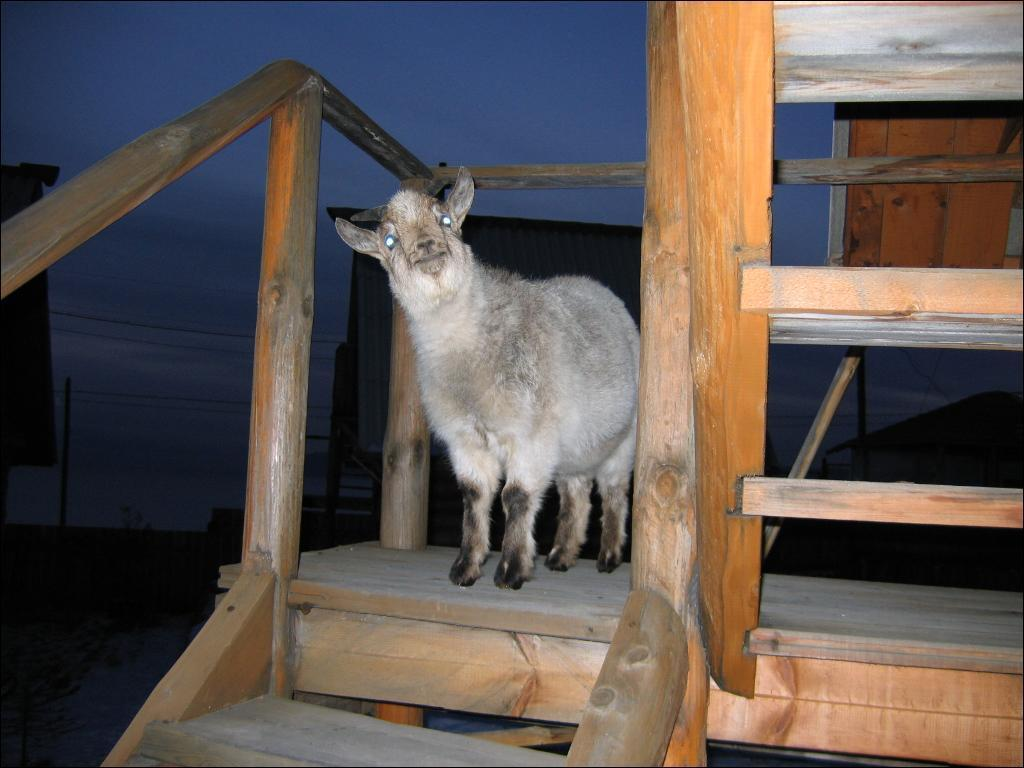What animal is in the image? There is a sheep in the image. What is the sheep standing on? The sheep is on a wooden surface. What can be seen in the background of the image? There are poles, wires, and the sky visible in the background of the image. Are there any other objects present in the background of the image? Yes, there are other objects present in the background of the image. Can you hear the ants laughing in the image? There are no ants or laughter present in the image; it features a sheep standing on a wooden surface with a background that includes poles, wires, and the sky. 